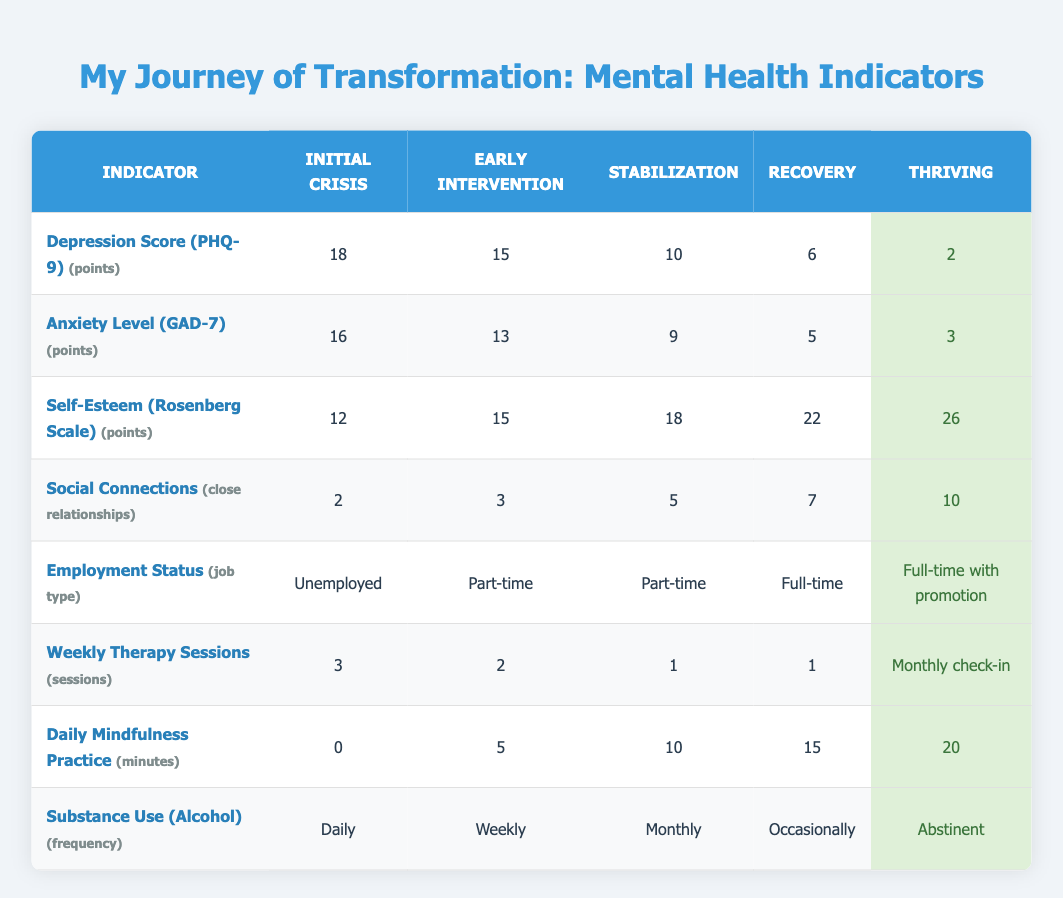What is the Depression Score during the Initial Crisis? The table indicates that the Depression Score (PHQ-9) during the Initial Crisis stage is 18 points, as shown in the corresponding row and column.
Answer: 18 What is the Anxiety Level during the Recovery stage? According to the table, the Anxiety Level (GAD-7) during the Recovery stage is 5 points, as reflected in the appropriate row and column for that stage.
Answer: 5 Was there an increase in Self-Esteem from Early Intervention to Stabilization? To determine this, we compare the Self-Esteem scores: Early Intervention is 15 points, and Stabilization is 18 points. Since 18 is greater than 15, it indicates an increase.
Answer: Yes What is the average Daily Mindfulness Practice time across all stages? The values for Daily Mindfulness Practice are 0, 5, 10, 15, and 20 minutes. Adding them gives 0 + 5 + 10 + 15 + 20 = 50 minutes. There are 5 stages, so the average is 50/5 = 10 minutes.
Answer: 10 Is the Social Connections score greater during Thriving compared to the Initial Crisis? The Social Connections score during Thriving is 10, while during the Initial Crisis it is 2. Since 10 is greater than 2, the statement is true.
Answer: Yes What is the difference in the Depression Score from Stabilization to Thriving? The Depression Score during Stabilization is 10, and during Thriving it is 2. The difference is calculated as 10 - 2 = 8 points, indicating a significant improvement.
Answer: 8 How many Weekly Therapy Sessions are reported in the Initial Crisis? The table shows that there are 3 Weekly Therapy Sessions reported in the Initial Crisis stage, directly indicated in the table.
Answer: 3 Is there any stage where a person has a Full-time job? Yes, the table shows that both Recovery and Thriving stages have Employment Status listed as Full-time, indicating that individuals reach full employment in these stages.
Answer: Yes What is the substance use frequency at the Stabilization stage? The indicator for Substance Use at the Stabilization stage indicates it is Monthly, as detailed in the respective row and column of the table.
Answer: Monthly 